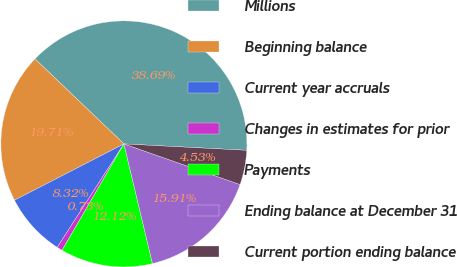Convert chart to OTSL. <chart><loc_0><loc_0><loc_500><loc_500><pie_chart><fcel>Millions<fcel>Beginning balance<fcel>Current year accruals<fcel>Changes in estimates for prior<fcel>Payments<fcel>Ending balance at December 31<fcel>Current portion ending balance<nl><fcel>38.69%<fcel>19.71%<fcel>8.32%<fcel>0.73%<fcel>12.12%<fcel>15.91%<fcel>4.53%<nl></chart> 